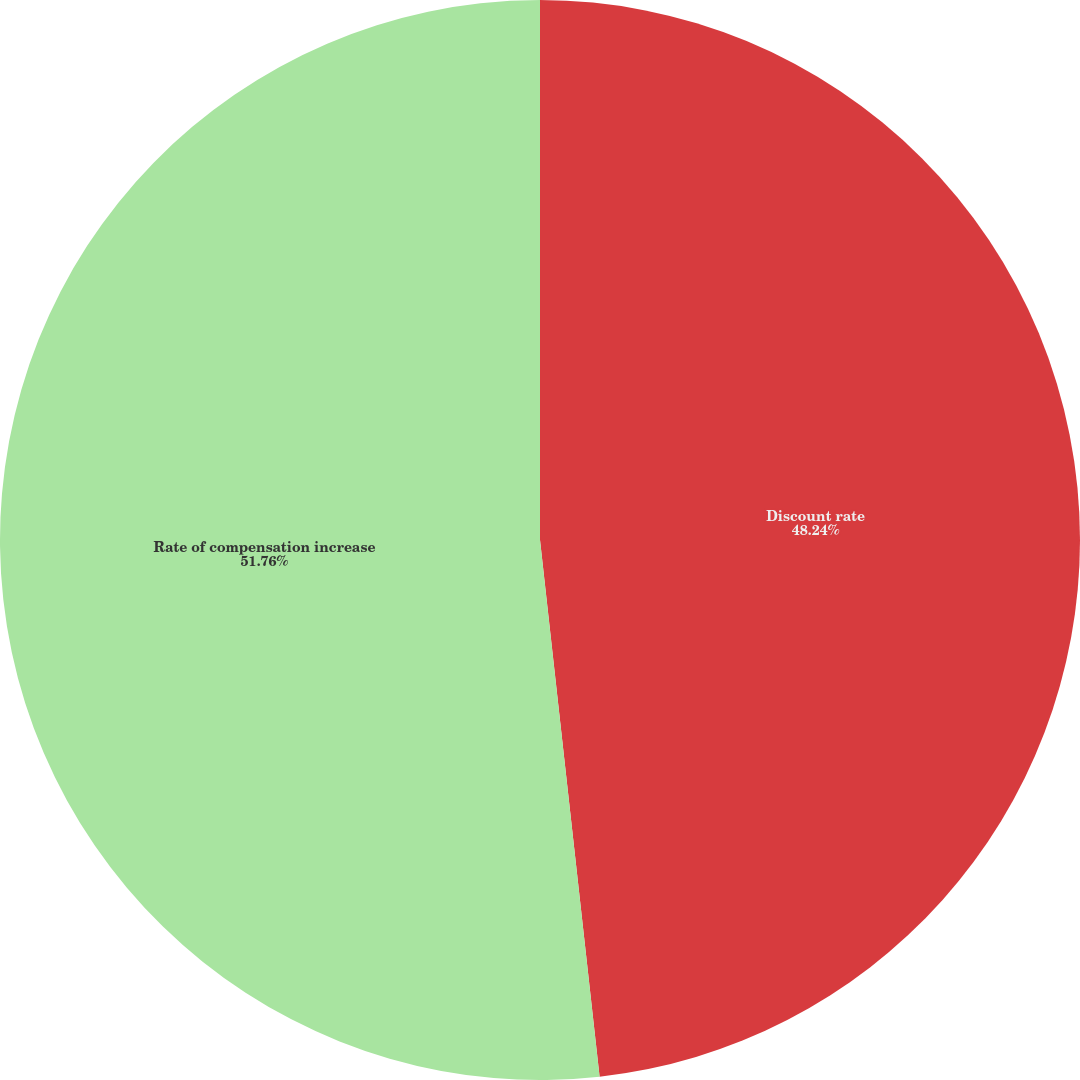Convert chart to OTSL. <chart><loc_0><loc_0><loc_500><loc_500><pie_chart><fcel>Discount rate<fcel>Rate of compensation increase<nl><fcel>48.24%<fcel>51.76%<nl></chart> 